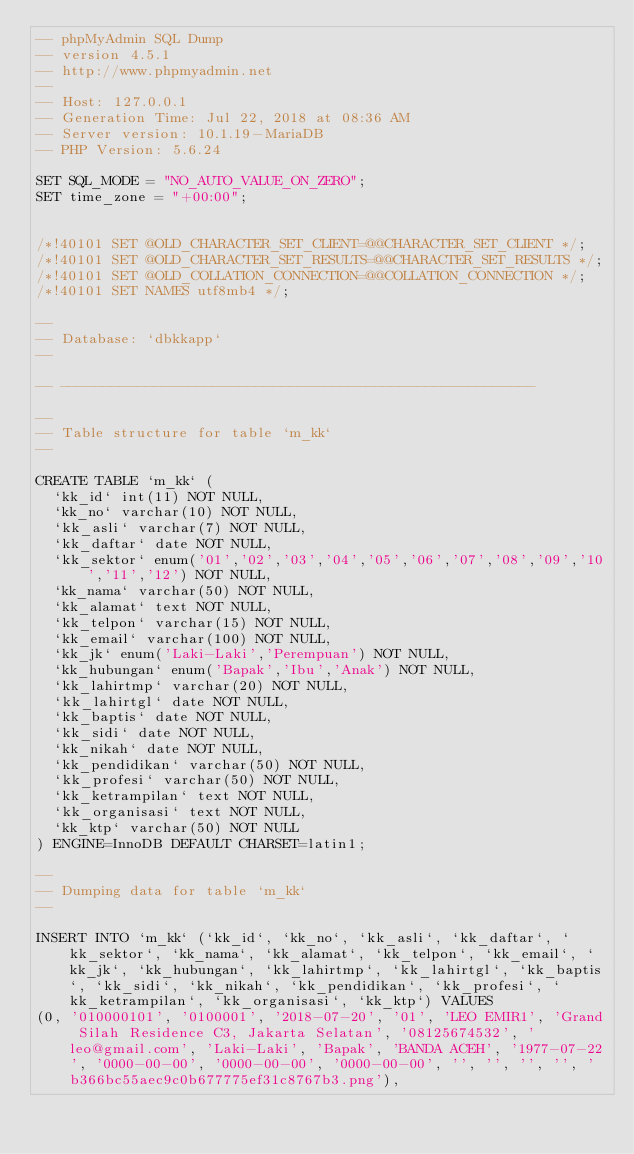Convert code to text. <code><loc_0><loc_0><loc_500><loc_500><_SQL_>-- phpMyAdmin SQL Dump
-- version 4.5.1
-- http://www.phpmyadmin.net
--
-- Host: 127.0.0.1
-- Generation Time: Jul 22, 2018 at 08:36 AM
-- Server version: 10.1.19-MariaDB
-- PHP Version: 5.6.24

SET SQL_MODE = "NO_AUTO_VALUE_ON_ZERO";
SET time_zone = "+00:00";


/*!40101 SET @OLD_CHARACTER_SET_CLIENT=@@CHARACTER_SET_CLIENT */;
/*!40101 SET @OLD_CHARACTER_SET_RESULTS=@@CHARACTER_SET_RESULTS */;
/*!40101 SET @OLD_COLLATION_CONNECTION=@@COLLATION_CONNECTION */;
/*!40101 SET NAMES utf8mb4 */;

--
-- Database: `dbkkapp`
--

-- --------------------------------------------------------

--
-- Table structure for table `m_kk`
--

CREATE TABLE `m_kk` (
  `kk_id` int(11) NOT NULL,
  `kk_no` varchar(10) NOT NULL,
  `kk_asli` varchar(7) NOT NULL,
  `kk_daftar` date NOT NULL,
  `kk_sektor` enum('01','02','03','04','05','06','07','08','09','10','11','12') NOT NULL,
  `kk_nama` varchar(50) NOT NULL,
  `kk_alamat` text NOT NULL,
  `kk_telpon` varchar(15) NOT NULL,
  `kk_email` varchar(100) NOT NULL,
  `kk_jk` enum('Laki-Laki','Perempuan') NOT NULL,
  `kk_hubungan` enum('Bapak','Ibu','Anak') NOT NULL,
  `kk_lahirtmp` varchar(20) NOT NULL,
  `kk_lahirtgl` date NOT NULL,
  `kk_baptis` date NOT NULL,
  `kk_sidi` date NOT NULL,
  `kk_nikah` date NOT NULL,
  `kk_pendidikan` varchar(50) NOT NULL,
  `kk_profesi` varchar(50) NOT NULL,
  `kk_ketrampilan` text NOT NULL,
  `kk_organisasi` text NOT NULL,
  `kk_ktp` varchar(50) NOT NULL
) ENGINE=InnoDB DEFAULT CHARSET=latin1;

--
-- Dumping data for table `m_kk`
--

INSERT INTO `m_kk` (`kk_id`, `kk_no`, `kk_asli`, `kk_daftar`, `kk_sektor`, `kk_nama`, `kk_alamat`, `kk_telpon`, `kk_email`, `kk_jk`, `kk_hubungan`, `kk_lahirtmp`, `kk_lahirtgl`, `kk_baptis`, `kk_sidi`, `kk_nikah`, `kk_pendidikan`, `kk_profesi`, `kk_ketrampilan`, `kk_organisasi`, `kk_ktp`) VALUES
(0, '010000101', '0100001', '2018-07-20', '01', 'LEO EMIR1', 'Grand Silah Residence C3, Jakarta Selatan', '08125674532', 'leo@gmail.com', 'Laki-Laki', 'Bapak', 'BANDA ACEH', '1977-07-22', '0000-00-00', '0000-00-00', '0000-00-00', '', '', '', '', 'b366bc55aec9c0b677775ef31c8767b3.png'),</code> 